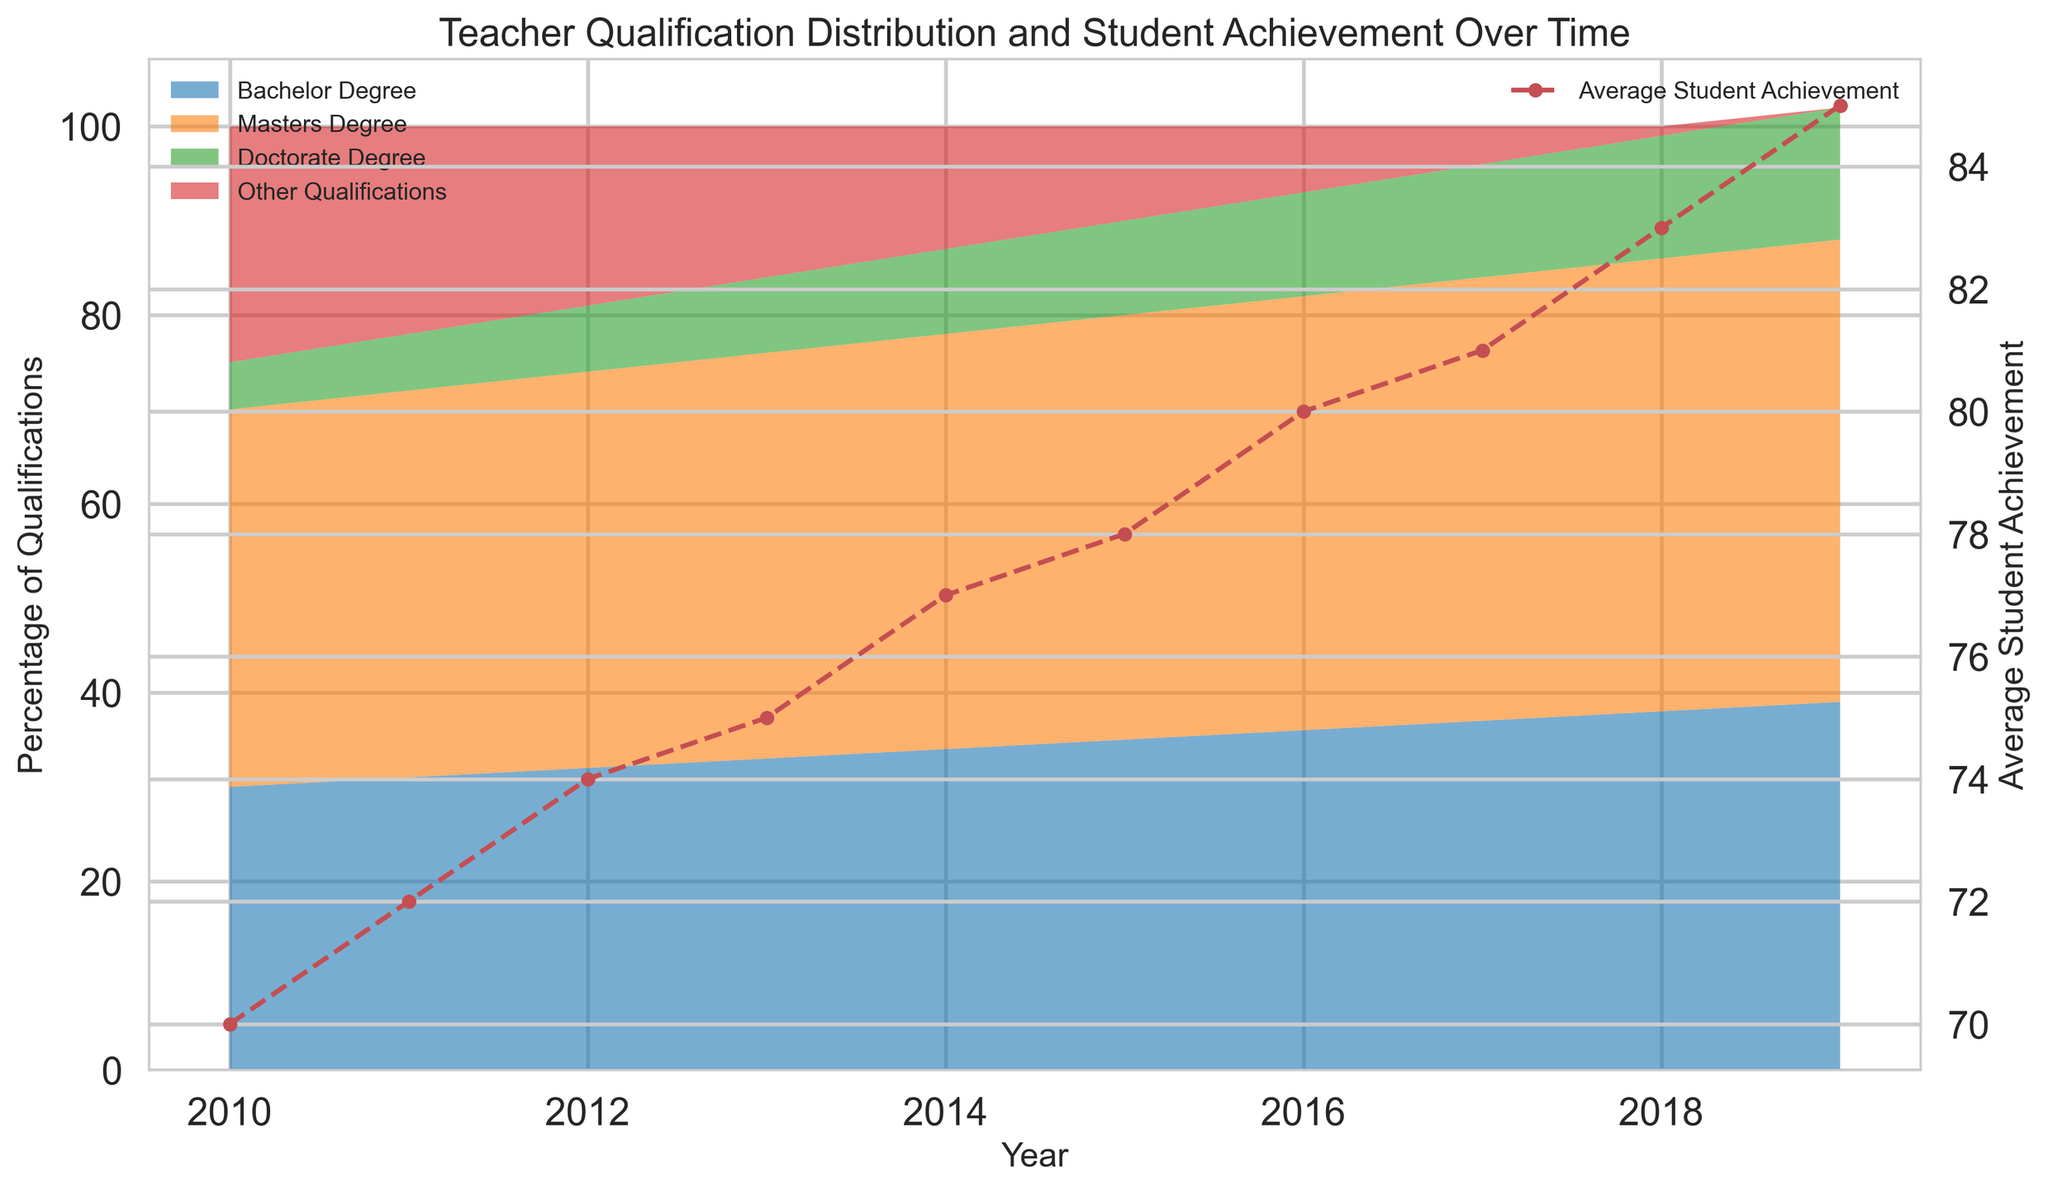Which qualification grew the most from 2010 to 2019? To find which qualification grew the most, subtract the 2010 value from the 2019 value for each qualification. For Bachelor Degree: 39 - 30 = 9. For Masters Degree: 49 - 40 = 9. For Doctorate Degree: 14 - 5 = 9. For Other Qualifications: 0 - 25 = -25. Bachelor Degree, Masters Degree, and Doctorate Degree all grew by 9 units.
Answer: Bachelor Degree, Masters Degree, and Doctorate Degree In which year did the average student achievement first exceed 80? Look at the line plot for the Average Student Achievement and find the year where the value first goes above 80. In 2016, the achievement is exactly 80. In 2017, it exceeds 80.
Answer: 2017 Which qualification had the largest percentage decrease from 2010 to 2019? Calculate the percentage decrease for each qualification by subtracting the 2019 value from the 2010 value, then divide by the 2010 value and multiply by 100. Bachelor Degree: ((30 - 39) / 30) * 100 = -30%. Masters Degree: ((40 - 49) / 40) * 100 = -22.5%. Doctorate Degree: ((5 - 14) / 5) * 100 = -180%. Other Qualifications: ((25 - 0) / 25) * 100 = 100%. Other Qualifications had the largest percentage decrease.
Answer: Other Qualifications How does the distribution of teacher qualifications relate to average student achievement over time? Refer to the area and line plots to observe any trends. As the percentage of teachers with higher qualifications (Masters and Doctorate) increases over the years, the average student achievement also increases. Conversely, the percentage of teachers with Other Qualifications decreases.
Answer: As teacher qualifications improve, student achievement increases Compare the percentage of teachers with a Master's Degree and Other Qualifications in 2012. Which was higher? In 2012, the percentage of teachers with a Master's Degree is 42 and with Other Qualifications is 19. Comparing the two, Master's Degree is higher.
Answer: Master's Degree What is the trend for teachers with bachelor's degrees over the years? Look at the area designated by "Bachelor Degree" over the years. From 2010 to 2019, the percentage of teachers with a Bachelor Degree steadily increases from 30 to 39.
Answer: Increasing At what rate did the average student achievement increase annually from 2010 to 2019? Calculate the difference in student achievement from 2010 to 2019 and divide by the number of years. (85 - 70) / (2019 - 2010) = 15 / 9 ≈ 1.67. The average student achievement increased roughly by 1.67 points per year.
Answer: 1.67 points per year 